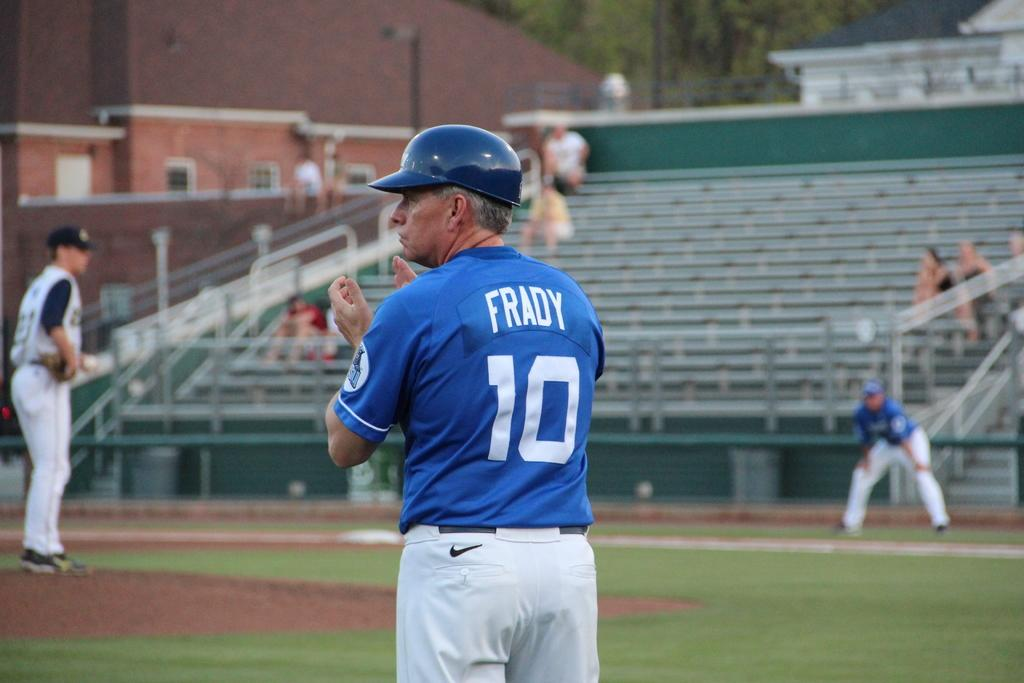<image>
Provide a brief description of the given image. a baseball diamond with the focus on the player frady 10 